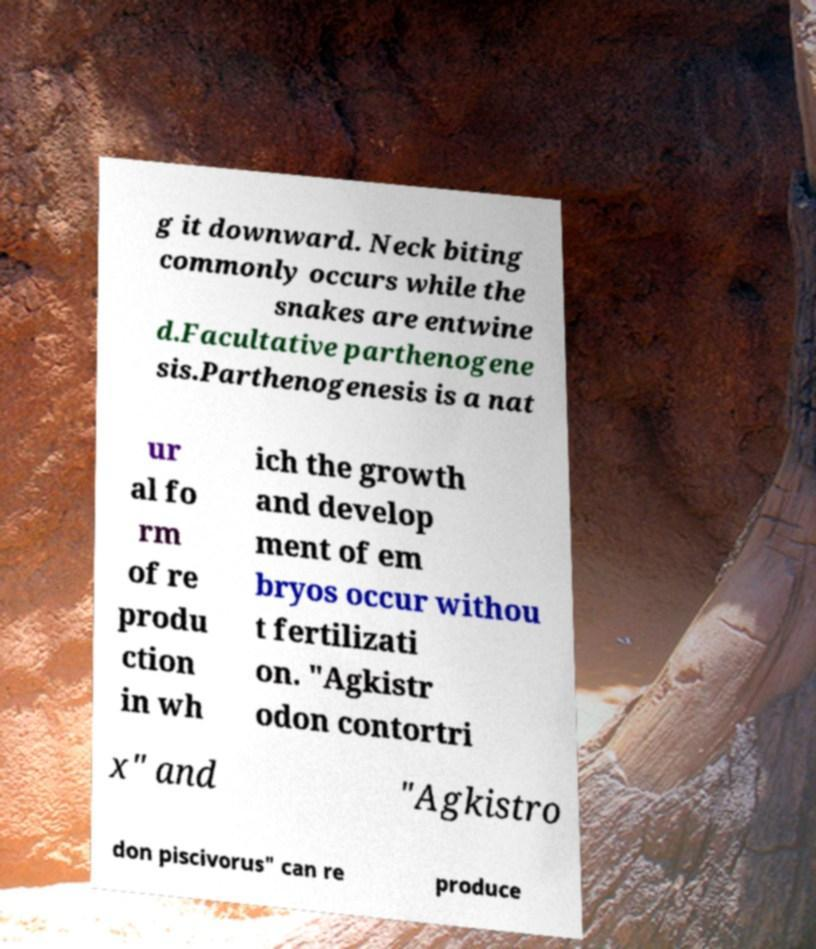Can you read and provide the text displayed in the image?This photo seems to have some interesting text. Can you extract and type it out for me? g it downward. Neck biting commonly occurs while the snakes are entwine d.Facultative parthenogene sis.Parthenogenesis is a nat ur al fo rm of re produ ction in wh ich the growth and develop ment of em bryos occur withou t fertilizati on. "Agkistr odon contortri x" and "Agkistro don piscivorus" can re produce 